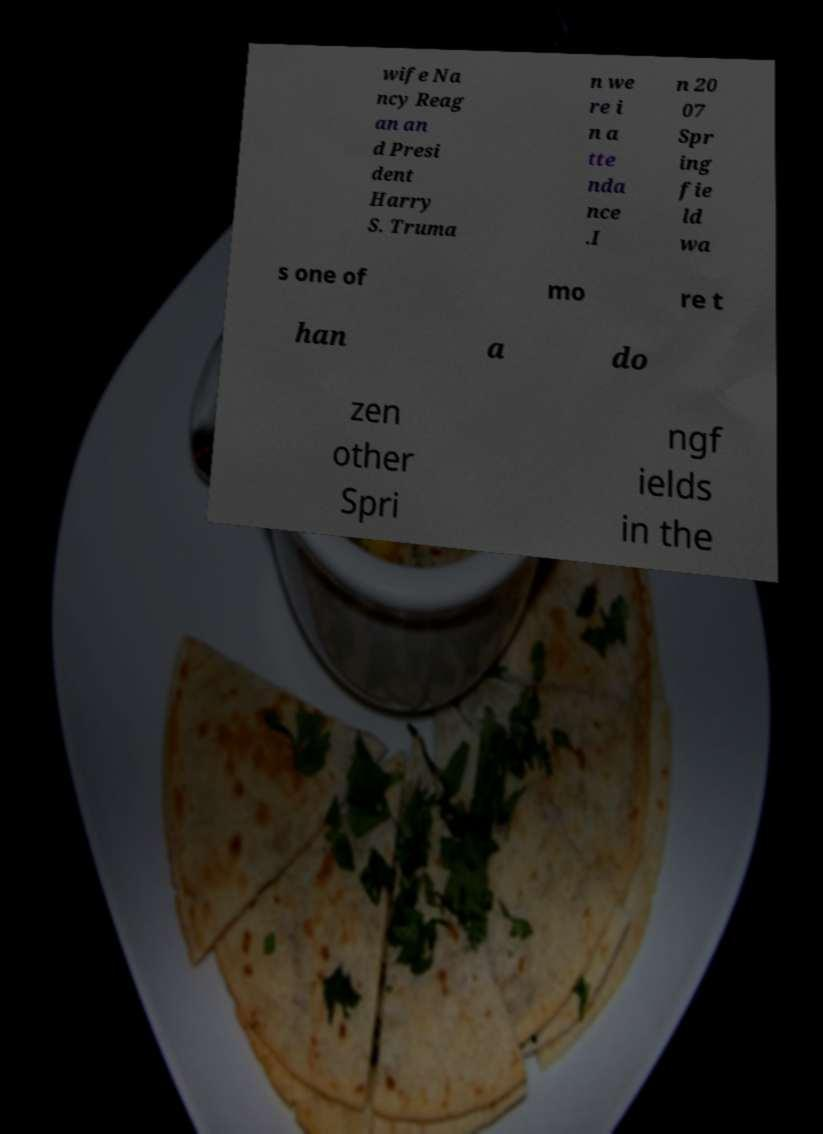Please identify and transcribe the text found in this image. wife Na ncy Reag an an d Presi dent Harry S. Truma n we re i n a tte nda nce .I n 20 07 Spr ing fie ld wa s one of mo re t han a do zen other Spri ngf ields in the 